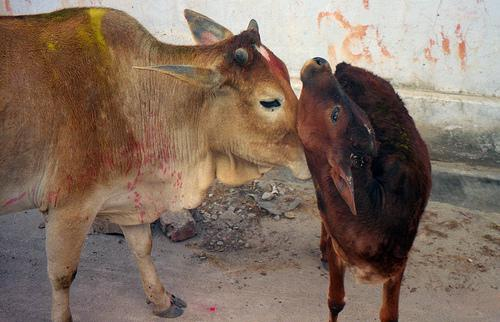Question: what kind of animals are these?
Choices:
A. They are sheep.
B. They are horses.
C. They are cows.
D. They are dogs.
Answer with the letter. Answer: C Question: what is in the background?
Choices:
A. A fence.
B. A wall.
C. Shrubs.
D. Trees.
Answer with the letter. Answer: B Question: what is in the picture?
Choices:
A. Two animals.
B. Man and dog.
C. Mother and child.
D. Elderly couple.
Answer with the letter. Answer: A Question: how is the weather?
Choices:
A. It is clear.
B. It is rainy.
C. It is cloudy.
D. It is cold.
Answer with the letter. Answer: A 